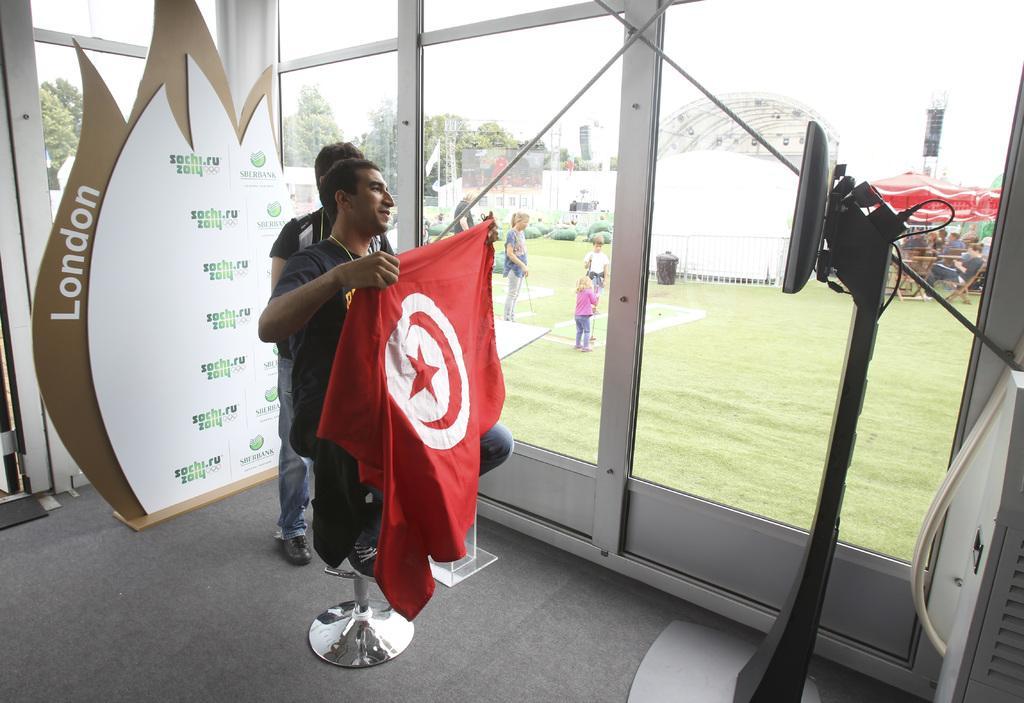In one or two sentences, can you explain what this image depicts? There is a person sitting on stool and holding a flag. In the back a person is standing. Also there is a wall with something written on that. There are glass walls. On the right side there is a device on a stand. Through the glass we can see grass, many people, trees, bin. And many people are sitting. 